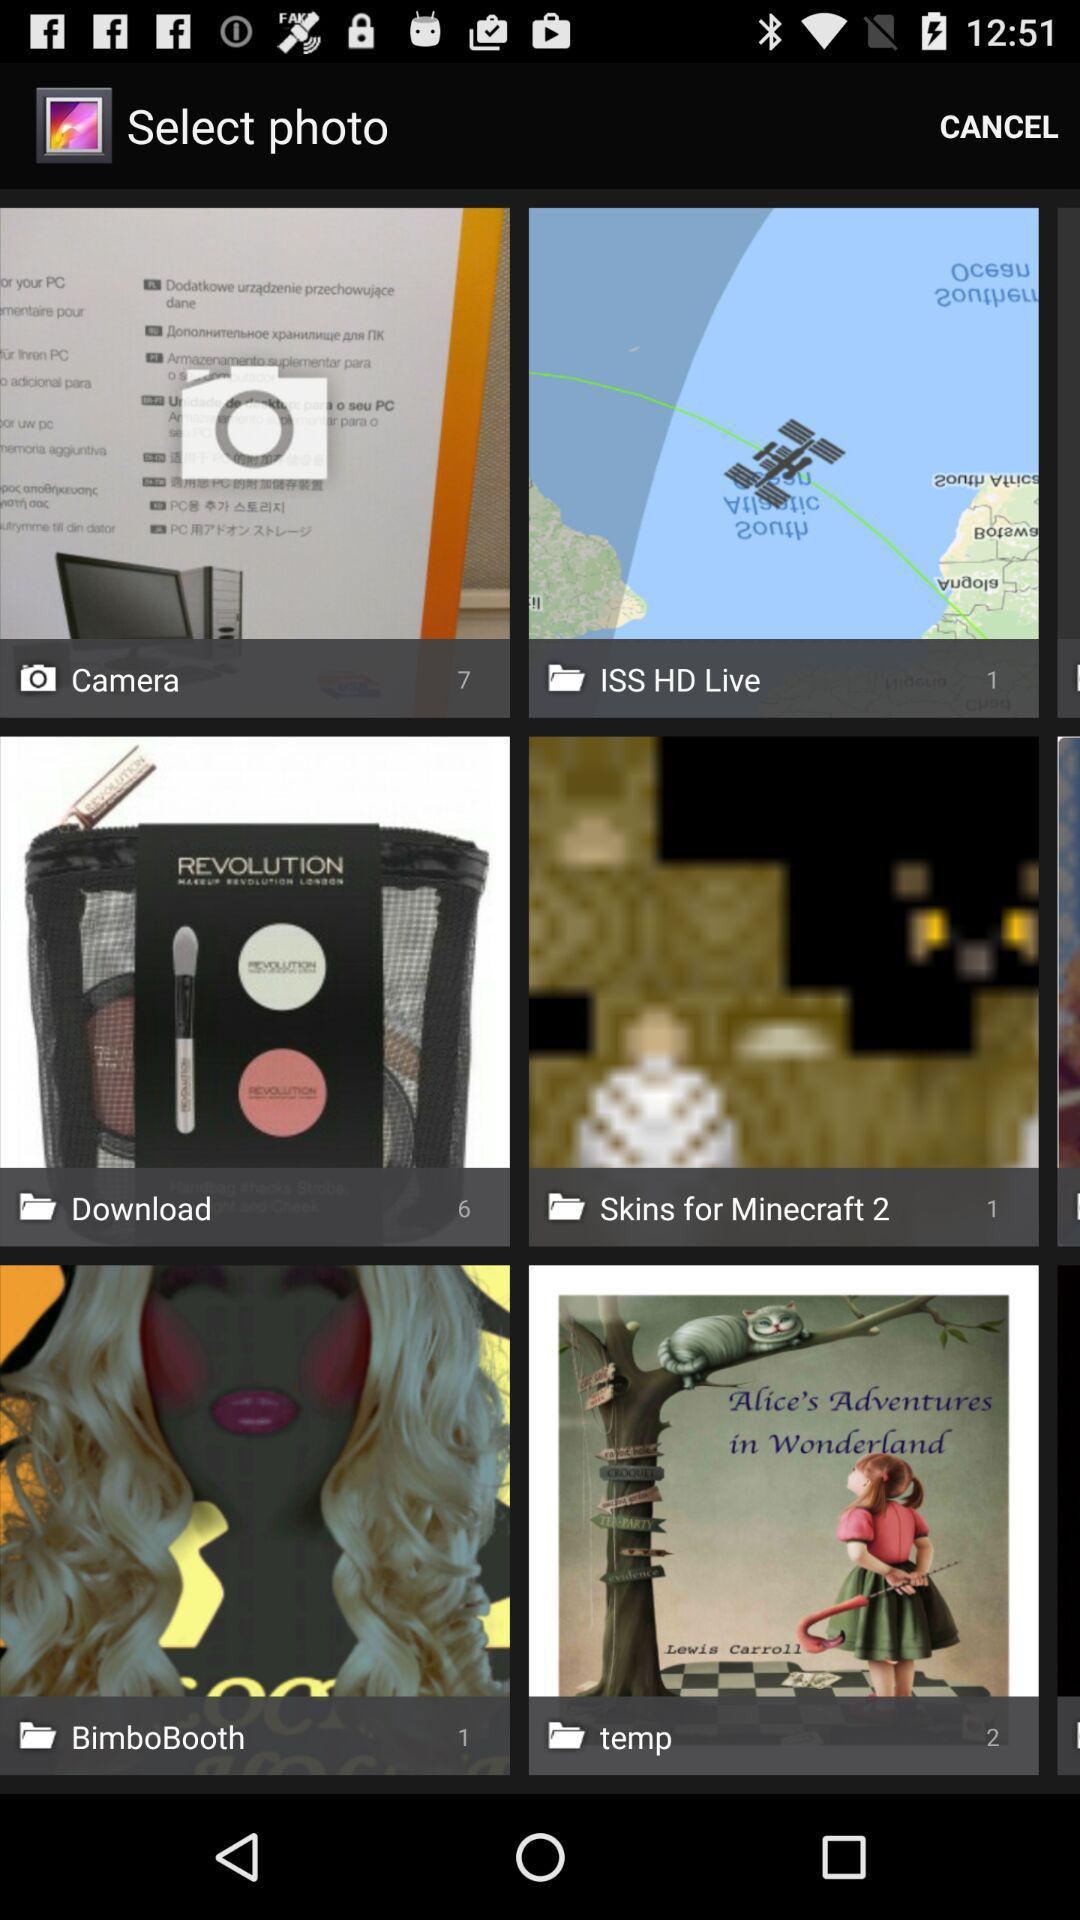What is the number of images in "ISS HD live" album? The number of images is one. 